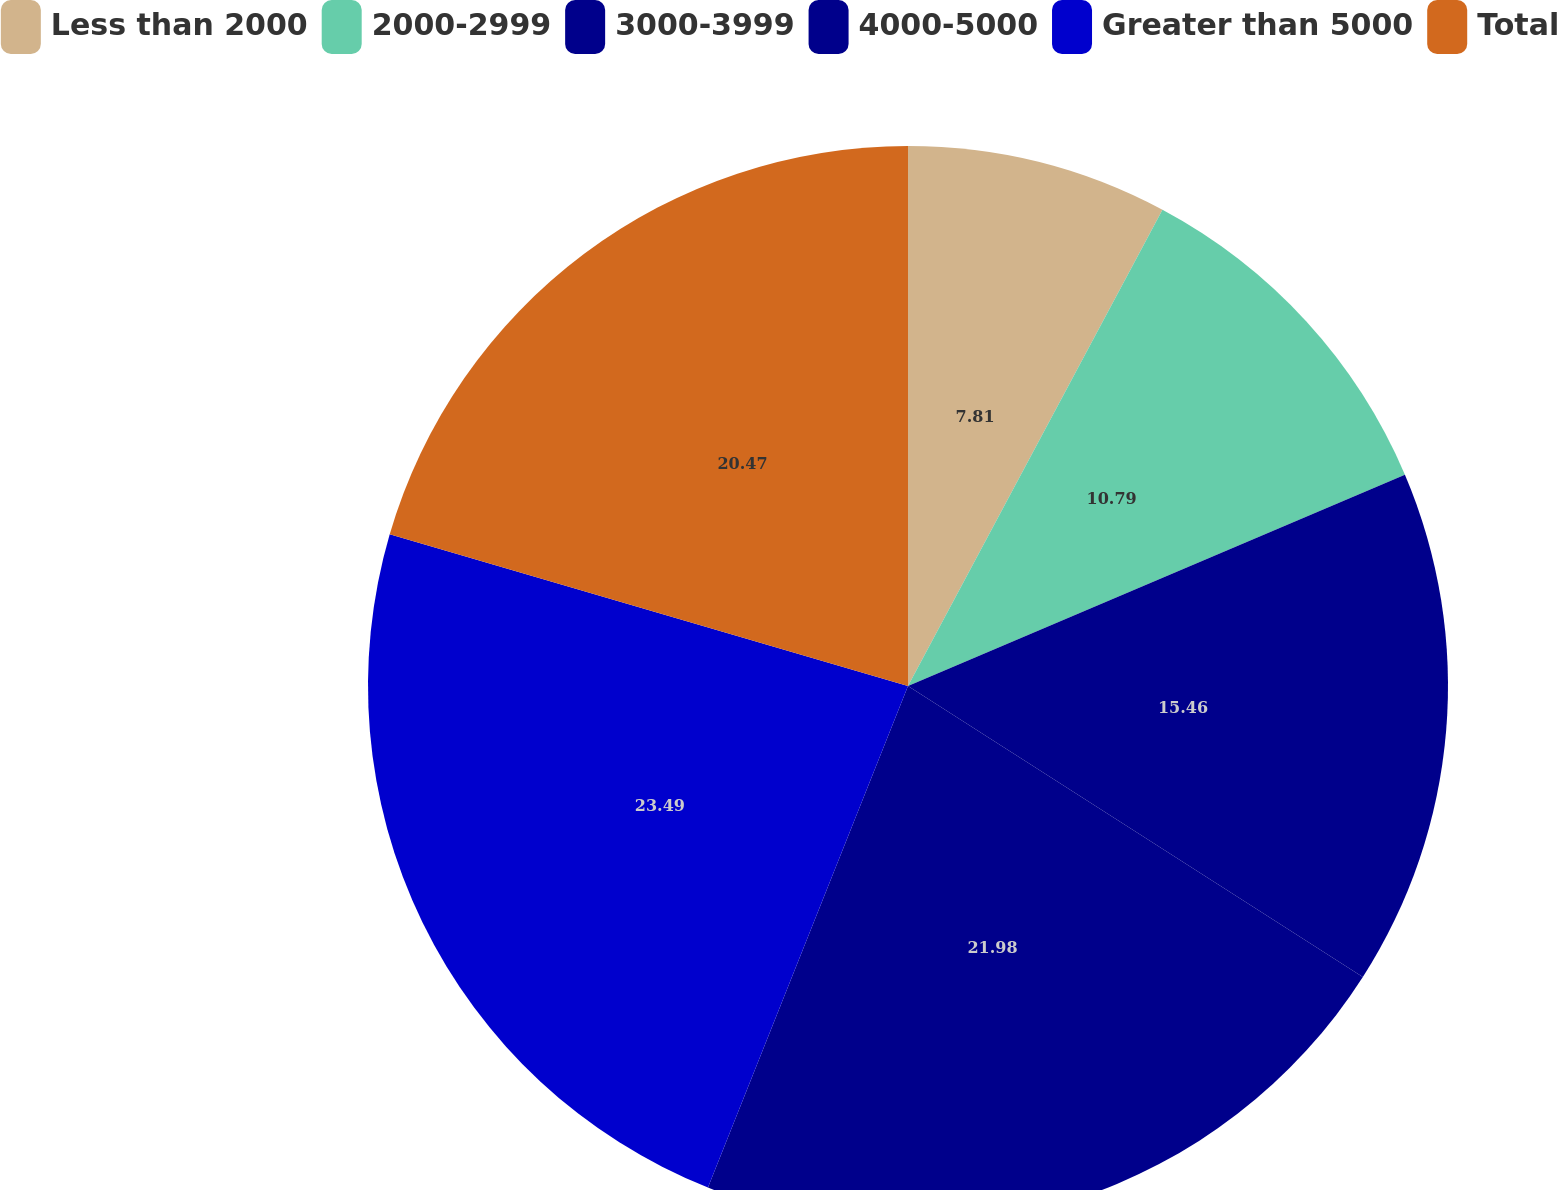Convert chart to OTSL. <chart><loc_0><loc_0><loc_500><loc_500><pie_chart><fcel>Less than 2000<fcel>2000-2999<fcel>3000-3999<fcel>4000-5000<fcel>Greater than 5000<fcel>Total<nl><fcel>7.81%<fcel>10.79%<fcel>15.46%<fcel>21.98%<fcel>23.49%<fcel>20.47%<nl></chart> 